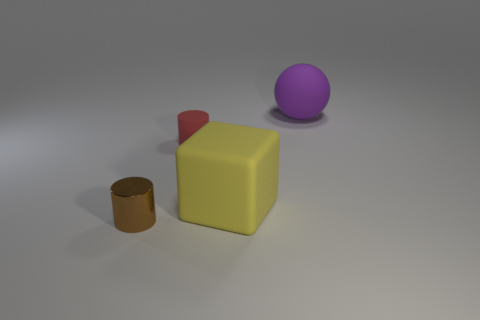Add 3 red matte cylinders. How many objects exist? 7 Subtract all blocks. How many objects are left? 3 Subtract all yellow things. Subtract all brown shiny objects. How many objects are left? 2 Add 2 small brown cylinders. How many small brown cylinders are left? 3 Add 1 small brown metal things. How many small brown metal things exist? 2 Subtract 1 red cylinders. How many objects are left? 3 